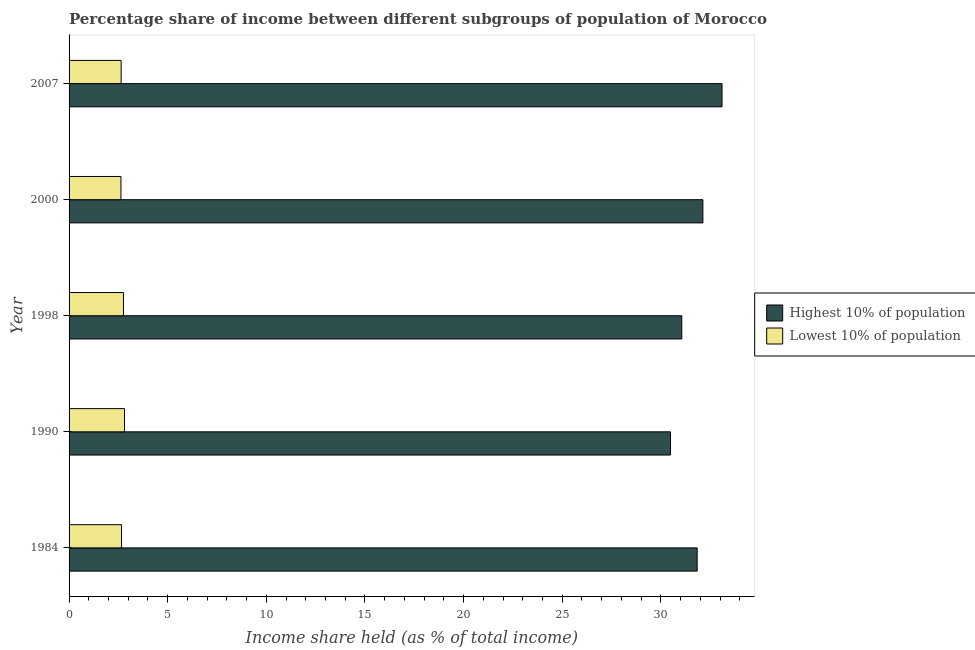How many different coloured bars are there?
Provide a short and direct response. 2. Are the number of bars per tick equal to the number of legend labels?
Your answer should be very brief. Yes. Are the number of bars on each tick of the Y-axis equal?
Provide a succinct answer. Yes. How many bars are there on the 2nd tick from the bottom?
Your response must be concise. 2. What is the income share held by lowest 10% of the population in 2000?
Your answer should be compact. 2.63. Across all years, what is the maximum income share held by lowest 10% of the population?
Provide a short and direct response. 2.81. Across all years, what is the minimum income share held by lowest 10% of the population?
Keep it short and to the point. 2.63. In which year was the income share held by highest 10% of the population maximum?
Give a very brief answer. 2007. What is the total income share held by highest 10% of the population in the graph?
Your answer should be very brief. 158.62. What is the difference between the income share held by highest 10% of the population in 1990 and that in 2007?
Provide a succinct answer. -2.61. What is the difference between the income share held by highest 10% of the population in 1990 and the income share held by lowest 10% of the population in 2007?
Provide a short and direct response. 27.85. In the year 1984, what is the difference between the income share held by lowest 10% of the population and income share held by highest 10% of the population?
Your answer should be very brief. -29.18. Is the income share held by lowest 10% of the population in 1984 less than that in 2007?
Provide a short and direct response. No. What is the difference between the highest and the lowest income share held by highest 10% of the population?
Your answer should be compact. 2.61. In how many years, is the income share held by lowest 10% of the population greater than the average income share held by lowest 10% of the population taken over all years?
Give a very brief answer. 2. What does the 1st bar from the top in 2000 represents?
Offer a very short reply. Lowest 10% of population. What does the 1st bar from the bottom in 1990 represents?
Ensure brevity in your answer.  Highest 10% of population. Are all the bars in the graph horizontal?
Give a very brief answer. Yes. What is the difference between two consecutive major ticks on the X-axis?
Keep it short and to the point. 5. Are the values on the major ticks of X-axis written in scientific E-notation?
Make the answer very short. No. Where does the legend appear in the graph?
Your response must be concise. Center right. How many legend labels are there?
Your answer should be very brief. 2. How are the legend labels stacked?
Ensure brevity in your answer.  Vertical. What is the title of the graph?
Offer a very short reply. Percentage share of income between different subgroups of population of Morocco. What is the label or title of the X-axis?
Offer a terse response. Income share held (as % of total income). What is the label or title of the Y-axis?
Make the answer very short. Year. What is the Income share held (as % of total income) in Highest 10% of population in 1984?
Offer a very short reply. 31.84. What is the Income share held (as % of total income) in Lowest 10% of population in 1984?
Your response must be concise. 2.66. What is the Income share held (as % of total income) in Highest 10% of population in 1990?
Your response must be concise. 30.49. What is the Income share held (as % of total income) of Lowest 10% of population in 1990?
Provide a short and direct response. 2.81. What is the Income share held (as % of total income) of Highest 10% of population in 1998?
Provide a succinct answer. 31.06. What is the Income share held (as % of total income) in Lowest 10% of population in 1998?
Keep it short and to the point. 2.76. What is the Income share held (as % of total income) of Highest 10% of population in 2000?
Ensure brevity in your answer.  32.13. What is the Income share held (as % of total income) in Lowest 10% of population in 2000?
Keep it short and to the point. 2.63. What is the Income share held (as % of total income) of Highest 10% of population in 2007?
Keep it short and to the point. 33.1. What is the Income share held (as % of total income) in Lowest 10% of population in 2007?
Keep it short and to the point. 2.64. Across all years, what is the maximum Income share held (as % of total income) in Highest 10% of population?
Provide a succinct answer. 33.1. Across all years, what is the maximum Income share held (as % of total income) in Lowest 10% of population?
Provide a succinct answer. 2.81. Across all years, what is the minimum Income share held (as % of total income) of Highest 10% of population?
Your answer should be very brief. 30.49. Across all years, what is the minimum Income share held (as % of total income) of Lowest 10% of population?
Provide a succinct answer. 2.63. What is the total Income share held (as % of total income) of Highest 10% of population in the graph?
Ensure brevity in your answer.  158.62. What is the total Income share held (as % of total income) in Lowest 10% of population in the graph?
Your answer should be very brief. 13.5. What is the difference between the Income share held (as % of total income) in Highest 10% of population in 1984 and that in 1990?
Keep it short and to the point. 1.35. What is the difference between the Income share held (as % of total income) in Lowest 10% of population in 1984 and that in 1990?
Give a very brief answer. -0.15. What is the difference between the Income share held (as % of total income) in Highest 10% of population in 1984 and that in 1998?
Provide a succinct answer. 0.78. What is the difference between the Income share held (as % of total income) of Lowest 10% of population in 1984 and that in 1998?
Make the answer very short. -0.1. What is the difference between the Income share held (as % of total income) in Highest 10% of population in 1984 and that in 2000?
Offer a very short reply. -0.29. What is the difference between the Income share held (as % of total income) in Highest 10% of population in 1984 and that in 2007?
Provide a short and direct response. -1.26. What is the difference between the Income share held (as % of total income) in Lowest 10% of population in 1984 and that in 2007?
Make the answer very short. 0.02. What is the difference between the Income share held (as % of total income) of Highest 10% of population in 1990 and that in 1998?
Make the answer very short. -0.57. What is the difference between the Income share held (as % of total income) of Lowest 10% of population in 1990 and that in 1998?
Make the answer very short. 0.05. What is the difference between the Income share held (as % of total income) in Highest 10% of population in 1990 and that in 2000?
Keep it short and to the point. -1.64. What is the difference between the Income share held (as % of total income) in Lowest 10% of population in 1990 and that in 2000?
Make the answer very short. 0.18. What is the difference between the Income share held (as % of total income) in Highest 10% of population in 1990 and that in 2007?
Ensure brevity in your answer.  -2.61. What is the difference between the Income share held (as % of total income) of Lowest 10% of population in 1990 and that in 2007?
Your answer should be compact. 0.17. What is the difference between the Income share held (as % of total income) of Highest 10% of population in 1998 and that in 2000?
Offer a very short reply. -1.07. What is the difference between the Income share held (as % of total income) of Lowest 10% of population in 1998 and that in 2000?
Provide a succinct answer. 0.13. What is the difference between the Income share held (as % of total income) in Highest 10% of population in 1998 and that in 2007?
Your answer should be very brief. -2.04. What is the difference between the Income share held (as % of total income) of Lowest 10% of population in 1998 and that in 2007?
Your answer should be compact. 0.12. What is the difference between the Income share held (as % of total income) of Highest 10% of population in 2000 and that in 2007?
Offer a terse response. -0.97. What is the difference between the Income share held (as % of total income) in Lowest 10% of population in 2000 and that in 2007?
Your answer should be very brief. -0.01. What is the difference between the Income share held (as % of total income) of Highest 10% of population in 1984 and the Income share held (as % of total income) of Lowest 10% of population in 1990?
Provide a succinct answer. 29.03. What is the difference between the Income share held (as % of total income) in Highest 10% of population in 1984 and the Income share held (as % of total income) in Lowest 10% of population in 1998?
Offer a very short reply. 29.08. What is the difference between the Income share held (as % of total income) in Highest 10% of population in 1984 and the Income share held (as % of total income) in Lowest 10% of population in 2000?
Offer a terse response. 29.21. What is the difference between the Income share held (as % of total income) in Highest 10% of population in 1984 and the Income share held (as % of total income) in Lowest 10% of population in 2007?
Your response must be concise. 29.2. What is the difference between the Income share held (as % of total income) of Highest 10% of population in 1990 and the Income share held (as % of total income) of Lowest 10% of population in 1998?
Keep it short and to the point. 27.73. What is the difference between the Income share held (as % of total income) in Highest 10% of population in 1990 and the Income share held (as % of total income) in Lowest 10% of population in 2000?
Offer a terse response. 27.86. What is the difference between the Income share held (as % of total income) of Highest 10% of population in 1990 and the Income share held (as % of total income) of Lowest 10% of population in 2007?
Give a very brief answer. 27.85. What is the difference between the Income share held (as % of total income) in Highest 10% of population in 1998 and the Income share held (as % of total income) in Lowest 10% of population in 2000?
Offer a terse response. 28.43. What is the difference between the Income share held (as % of total income) in Highest 10% of population in 1998 and the Income share held (as % of total income) in Lowest 10% of population in 2007?
Your response must be concise. 28.42. What is the difference between the Income share held (as % of total income) in Highest 10% of population in 2000 and the Income share held (as % of total income) in Lowest 10% of population in 2007?
Make the answer very short. 29.49. What is the average Income share held (as % of total income) in Highest 10% of population per year?
Give a very brief answer. 31.72. What is the average Income share held (as % of total income) in Lowest 10% of population per year?
Offer a terse response. 2.7. In the year 1984, what is the difference between the Income share held (as % of total income) of Highest 10% of population and Income share held (as % of total income) of Lowest 10% of population?
Provide a succinct answer. 29.18. In the year 1990, what is the difference between the Income share held (as % of total income) in Highest 10% of population and Income share held (as % of total income) in Lowest 10% of population?
Give a very brief answer. 27.68. In the year 1998, what is the difference between the Income share held (as % of total income) in Highest 10% of population and Income share held (as % of total income) in Lowest 10% of population?
Offer a terse response. 28.3. In the year 2000, what is the difference between the Income share held (as % of total income) of Highest 10% of population and Income share held (as % of total income) of Lowest 10% of population?
Ensure brevity in your answer.  29.5. In the year 2007, what is the difference between the Income share held (as % of total income) of Highest 10% of population and Income share held (as % of total income) of Lowest 10% of population?
Provide a short and direct response. 30.46. What is the ratio of the Income share held (as % of total income) in Highest 10% of population in 1984 to that in 1990?
Your answer should be compact. 1.04. What is the ratio of the Income share held (as % of total income) in Lowest 10% of population in 1984 to that in 1990?
Offer a terse response. 0.95. What is the ratio of the Income share held (as % of total income) of Highest 10% of population in 1984 to that in 1998?
Your response must be concise. 1.03. What is the ratio of the Income share held (as % of total income) in Lowest 10% of population in 1984 to that in 1998?
Provide a short and direct response. 0.96. What is the ratio of the Income share held (as % of total income) in Highest 10% of population in 1984 to that in 2000?
Give a very brief answer. 0.99. What is the ratio of the Income share held (as % of total income) of Lowest 10% of population in 1984 to that in 2000?
Provide a succinct answer. 1.01. What is the ratio of the Income share held (as % of total income) in Highest 10% of population in 1984 to that in 2007?
Keep it short and to the point. 0.96. What is the ratio of the Income share held (as % of total income) in Lowest 10% of population in 1984 to that in 2007?
Your response must be concise. 1.01. What is the ratio of the Income share held (as % of total income) of Highest 10% of population in 1990 to that in 1998?
Your response must be concise. 0.98. What is the ratio of the Income share held (as % of total income) in Lowest 10% of population in 1990 to that in 1998?
Ensure brevity in your answer.  1.02. What is the ratio of the Income share held (as % of total income) of Highest 10% of population in 1990 to that in 2000?
Provide a short and direct response. 0.95. What is the ratio of the Income share held (as % of total income) of Lowest 10% of population in 1990 to that in 2000?
Give a very brief answer. 1.07. What is the ratio of the Income share held (as % of total income) in Highest 10% of population in 1990 to that in 2007?
Keep it short and to the point. 0.92. What is the ratio of the Income share held (as % of total income) of Lowest 10% of population in 1990 to that in 2007?
Ensure brevity in your answer.  1.06. What is the ratio of the Income share held (as % of total income) of Highest 10% of population in 1998 to that in 2000?
Your answer should be very brief. 0.97. What is the ratio of the Income share held (as % of total income) of Lowest 10% of population in 1998 to that in 2000?
Offer a terse response. 1.05. What is the ratio of the Income share held (as % of total income) of Highest 10% of population in 1998 to that in 2007?
Provide a short and direct response. 0.94. What is the ratio of the Income share held (as % of total income) in Lowest 10% of population in 1998 to that in 2007?
Provide a short and direct response. 1.05. What is the ratio of the Income share held (as % of total income) of Highest 10% of population in 2000 to that in 2007?
Offer a terse response. 0.97. What is the difference between the highest and the lowest Income share held (as % of total income) in Highest 10% of population?
Offer a very short reply. 2.61. What is the difference between the highest and the lowest Income share held (as % of total income) of Lowest 10% of population?
Give a very brief answer. 0.18. 